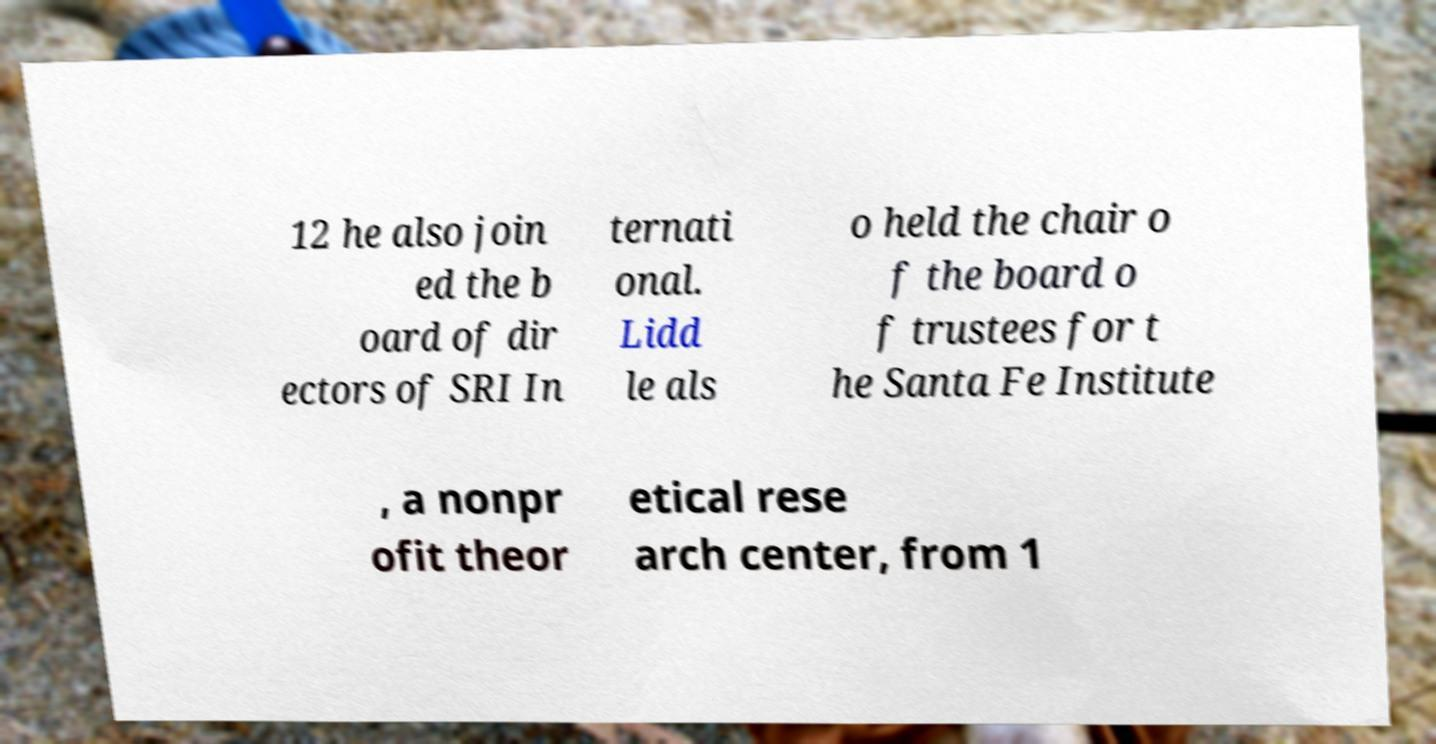Could you assist in decoding the text presented in this image and type it out clearly? 12 he also join ed the b oard of dir ectors of SRI In ternati onal. Lidd le als o held the chair o f the board o f trustees for t he Santa Fe Institute , a nonpr ofit theor etical rese arch center, from 1 